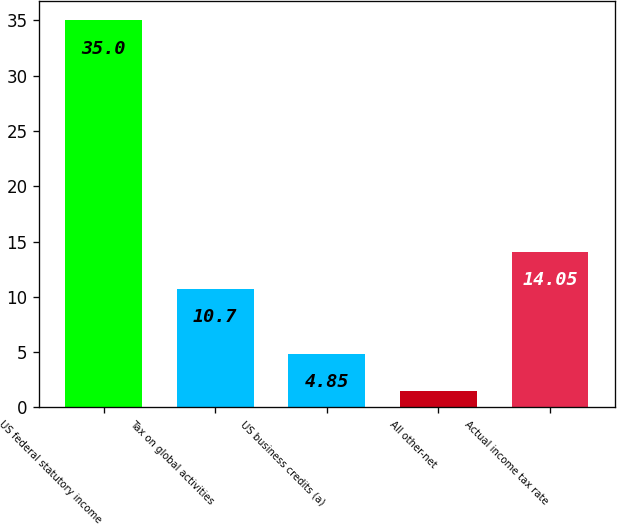<chart> <loc_0><loc_0><loc_500><loc_500><bar_chart><fcel>US federal statutory income<fcel>Tax on global activities<fcel>US business credits (a)<fcel>All other-net<fcel>Actual income tax rate<nl><fcel>35<fcel>10.7<fcel>4.85<fcel>1.5<fcel>14.05<nl></chart> 